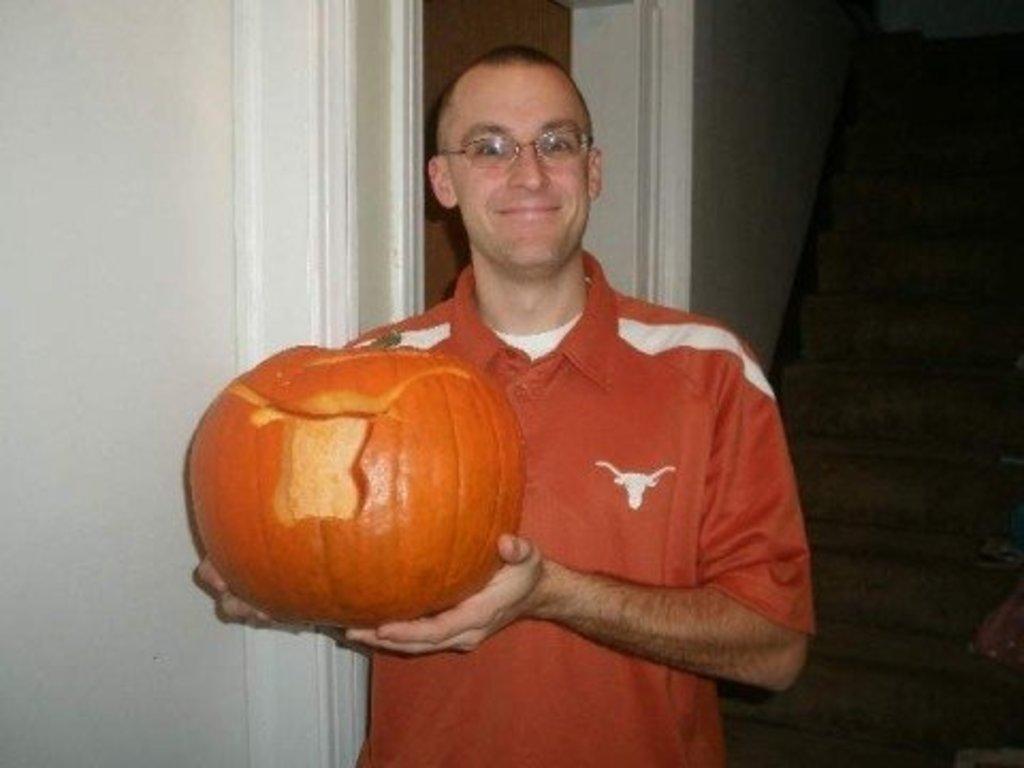Describe this image in one or two sentences. In this image I can see a person wearing orange and white colored t shirt is standing and holding a pumpkin which is orange in color in his hands. In the background I can see few stairs and the white colored wall. 